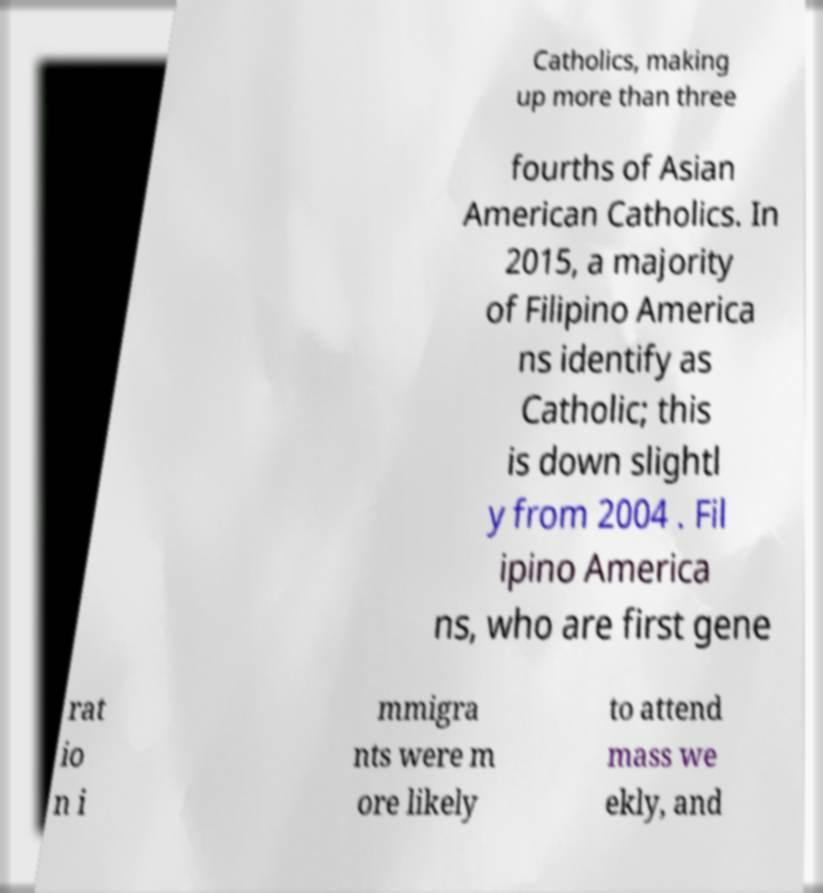Can you read and provide the text displayed in the image?This photo seems to have some interesting text. Can you extract and type it out for me? Catholics, making up more than three fourths of Asian American Catholics. In 2015, a majority of Filipino America ns identify as Catholic; this is down slightl y from 2004 . Fil ipino America ns, who are first gene rat io n i mmigra nts were m ore likely to attend mass we ekly, and 